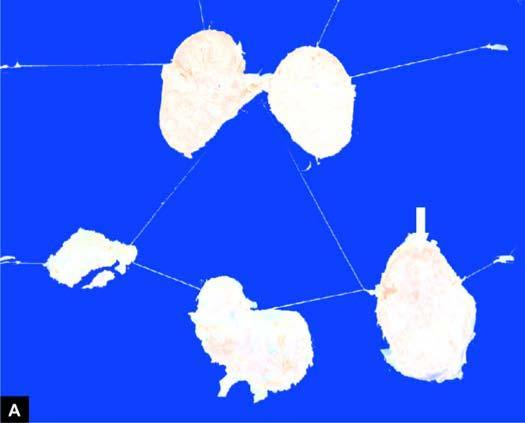does a cut section of matted mass of lymph nodes show merging capsules and large areas of caseation necrosis?
Answer the question using a single word or phrase. Yes 